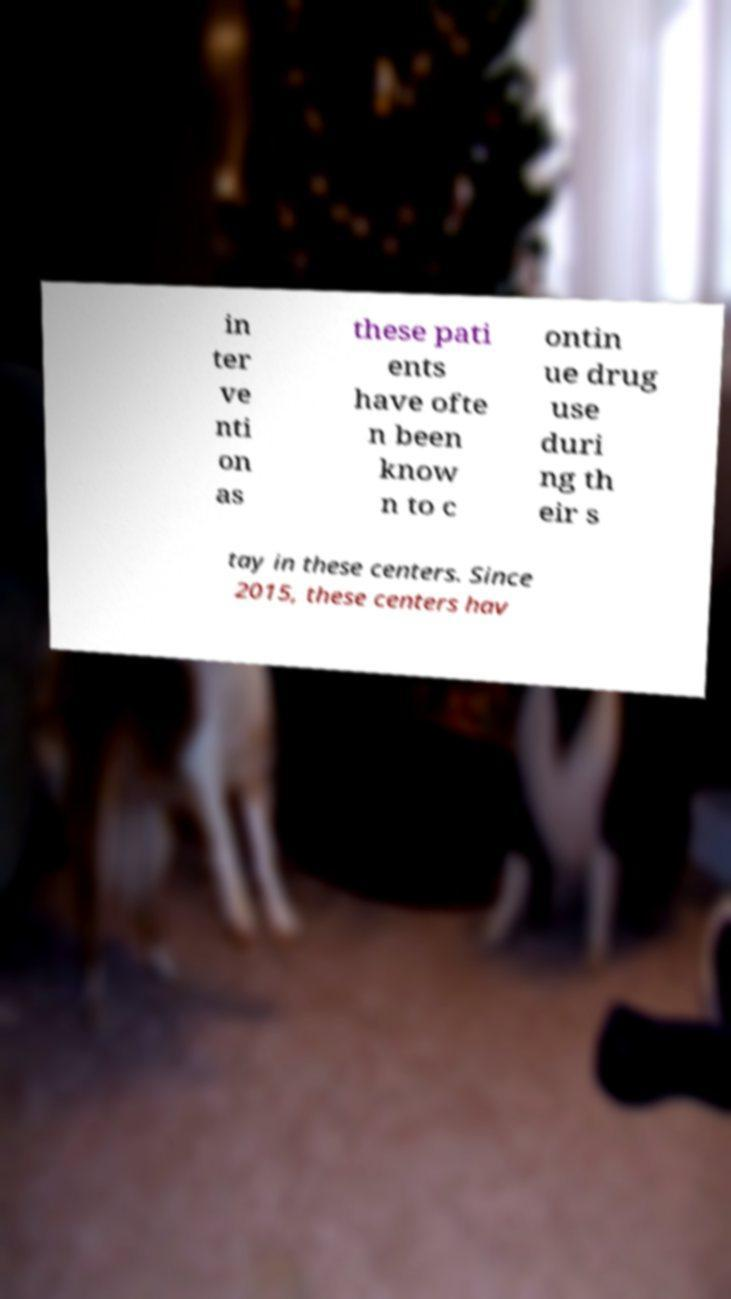Could you assist in decoding the text presented in this image and type it out clearly? in ter ve nti on as these pati ents have ofte n been know n to c ontin ue drug use duri ng th eir s tay in these centers. Since 2015, these centers hav 